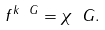Convert formula to latex. <formula><loc_0><loc_0><loc_500><loc_500>f ^ { k _ { \ } G } = \chi _ { \ } G .</formula> 